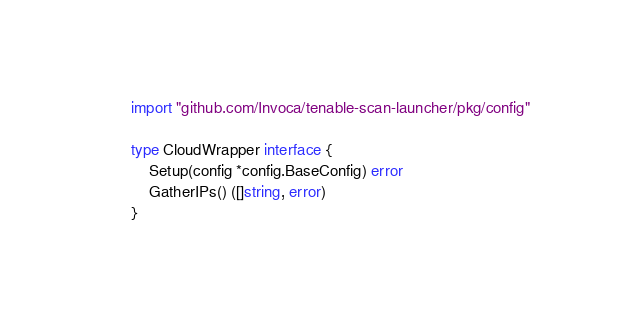<code> <loc_0><loc_0><loc_500><loc_500><_Go_>
import "github.com/Invoca/tenable-scan-launcher/pkg/config"

type CloudWrapper interface {
	Setup(config *config.BaseConfig) error
	GatherIPs() ([]string, error)
}
</code> 